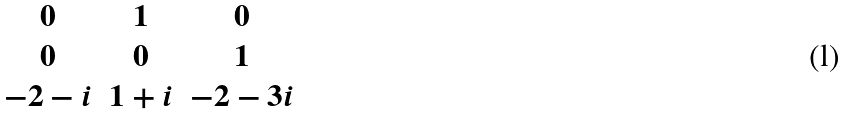Convert formula to latex. <formula><loc_0><loc_0><loc_500><loc_500>\begin{matrix} 0 & 1 & 0 \\ 0 & 0 & 1 \\ - 2 - i & 1 + i & - 2 - 3 i \end{matrix}</formula> 